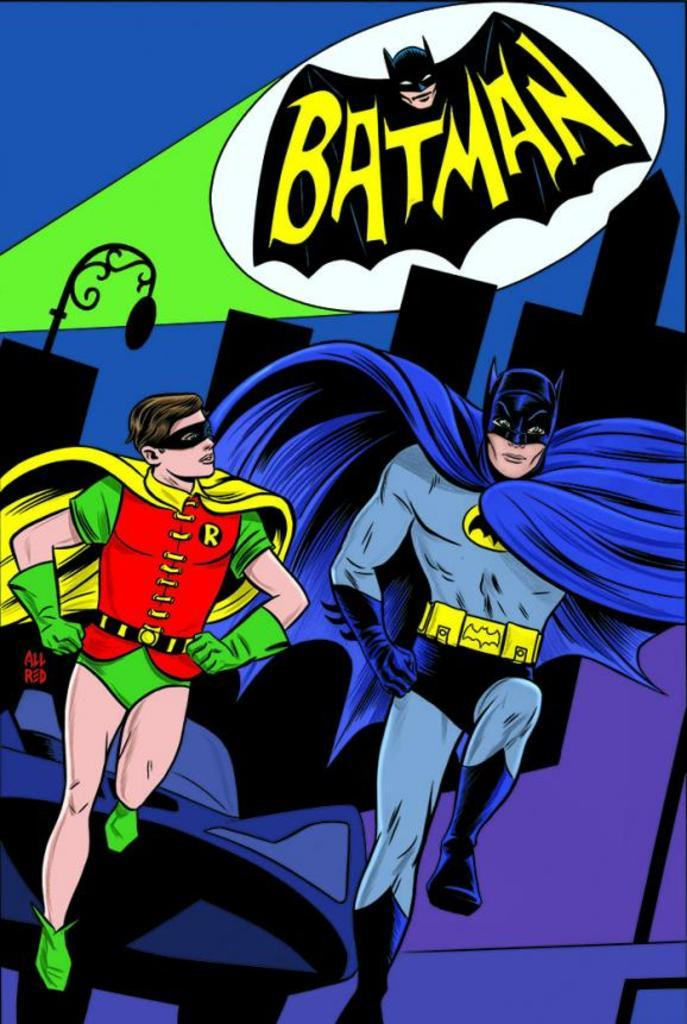What is the main subject of the image? The image contains a cartoon of men. What are the men wearing in the image? The men are wearing blue and red dresses. What word is written at the top of the image? The word "BATMAN" is written at the top of the image. What color is the background of the image? The background of the image is blue in color. What type of verse can be heard being recited by the men in the image? There is no indication in the image that the men are reciting any verse, so it cannot be determined from the picture. 